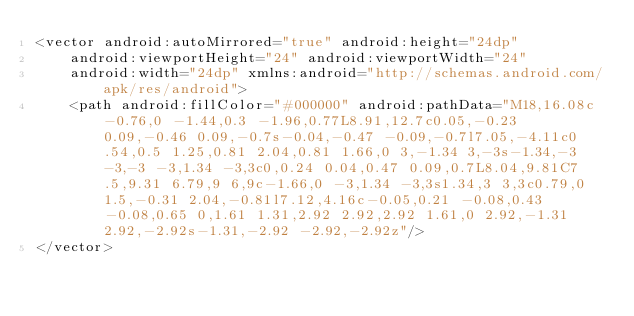<code> <loc_0><loc_0><loc_500><loc_500><_XML_><vector android:autoMirrored="true" android:height="24dp"
    android:viewportHeight="24" android:viewportWidth="24"
    android:width="24dp" xmlns:android="http://schemas.android.com/apk/res/android">
    <path android:fillColor="#000000" android:pathData="M18,16.08c-0.76,0 -1.44,0.3 -1.96,0.77L8.91,12.7c0.05,-0.23 0.09,-0.46 0.09,-0.7s-0.04,-0.47 -0.09,-0.7l7.05,-4.11c0.54,0.5 1.25,0.81 2.04,0.81 1.66,0 3,-1.34 3,-3s-1.34,-3 -3,-3 -3,1.34 -3,3c0,0.24 0.04,0.47 0.09,0.7L8.04,9.81C7.5,9.31 6.79,9 6,9c-1.66,0 -3,1.34 -3,3s1.34,3 3,3c0.79,0 1.5,-0.31 2.04,-0.81l7.12,4.16c-0.05,0.21 -0.08,0.43 -0.08,0.65 0,1.61 1.31,2.92 2.92,2.92 1.61,0 2.92,-1.31 2.92,-2.92s-1.31,-2.92 -2.92,-2.92z"/>
</vector>
</code> 